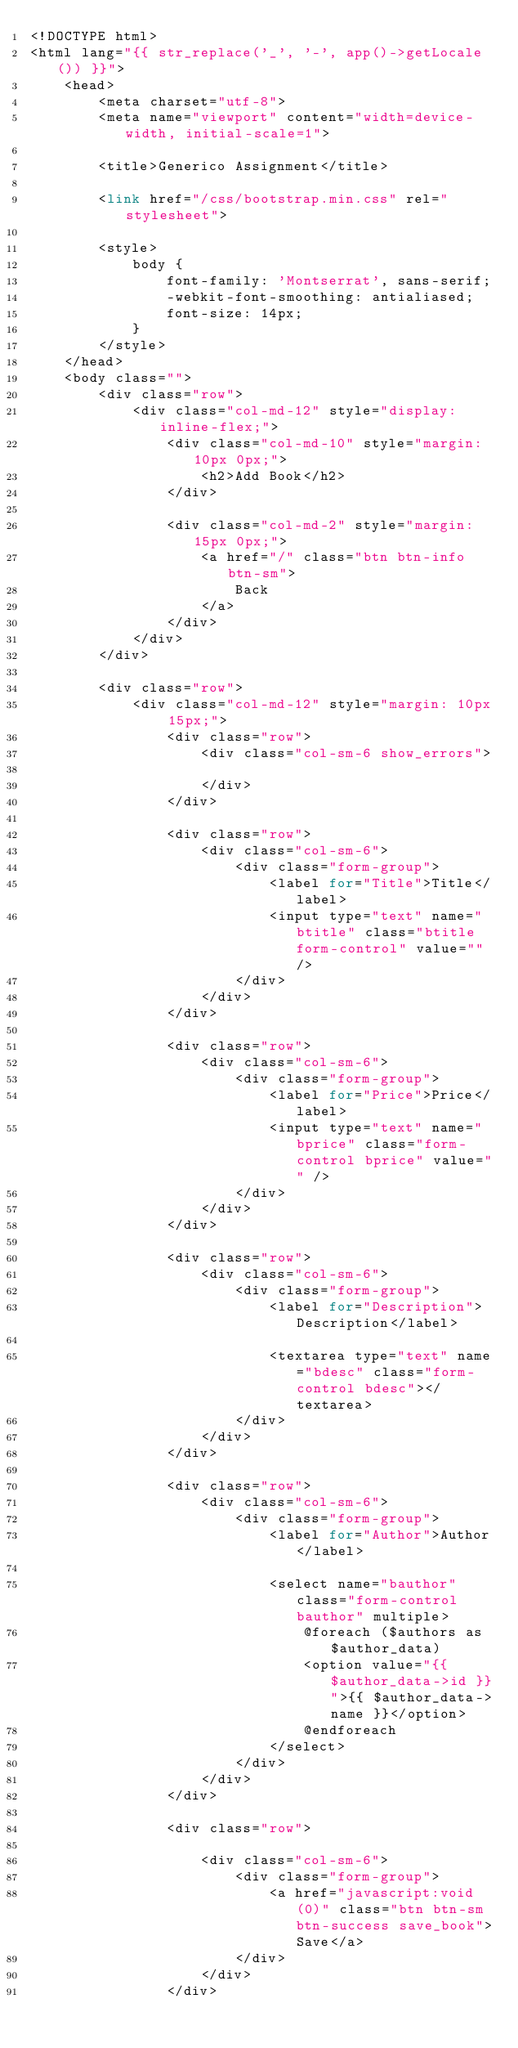Convert code to text. <code><loc_0><loc_0><loc_500><loc_500><_PHP_><!DOCTYPE html>
<html lang="{{ str_replace('_', '-', app()->getLocale()) }}">
    <head>
        <meta charset="utf-8">
        <meta name="viewport" content="width=device-width, initial-scale=1">

        <title>Generico Assignment</title>

        <link href="/css/bootstrap.min.css" rel="stylesheet">

        <style>
            body {
                font-family: 'Montserrat', sans-serif;
                -webkit-font-smoothing: antialiased;
                font-size: 14px;
            }
        </style>
    </head>
    <body class="">
        <div class="row">
            <div class="col-md-12" style="display: inline-flex;">
                <div class="col-md-10" style="margin: 10px 0px;">
                    <h2>Add Book</h2>
                </div>

                <div class="col-md-2" style="margin: 15px 0px;">
                    <a href="/" class="btn btn-info btn-sm">
                        Back
                    </a>
                </div>
            </div>
        </div>

        <div class="row">
            <div class="col-md-12" style="margin: 10px 15px;">
                <div class="row">
                    <div class="col-sm-6 show_errors">
                        
                    </div>
                </div>

                <div class="row">
                    <div class="col-sm-6">
                        <div class="form-group">
                            <label for="Title">Title</label>
                            <input type="text" name="btitle" class="btitle form-control" value="" />
                        </div>
                    </div>
                </div>

                <div class="row">
                    <div class="col-sm-6">
                        <div class="form-group">
                            <label for="Price">Price</label>
                            <input type="text" name="bprice" class="form-control bprice" value="" />
                        </div>
                    </div>
                </div>

                <div class="row">
                    <div class="col-sm-6">
                        <div class="form-group">
                            <label for="Description">Description</label>
                            
                            <textarea type="text" name="bdesc" class="form-control bdesc"></textarea>
                        </div>
                    </div>
                </div>

                <div class="row">
                    <div class="col-sm-6">
                        <div class="form-group">
                            <label for="Author">Author</label>
                            
                            <select name="bauthor" class="form-control bauthor" multiple>
                                @foreach ($authors as $author_data)
                                <option value="{{ $author_data->id }}">{{ $author_data->name }}</option>
                                @endforeach
                            </select>
                        </div>
                    </div>
                </div>

                <div class="row">
                                    
                    <div class="col-sm-6">
                        <div class="form-group">
                            <a href="javascript:void(0)" class="btn btn-sm btn-success save_book">Save</a>
                        </div>
                    </div>
                </div></code> 